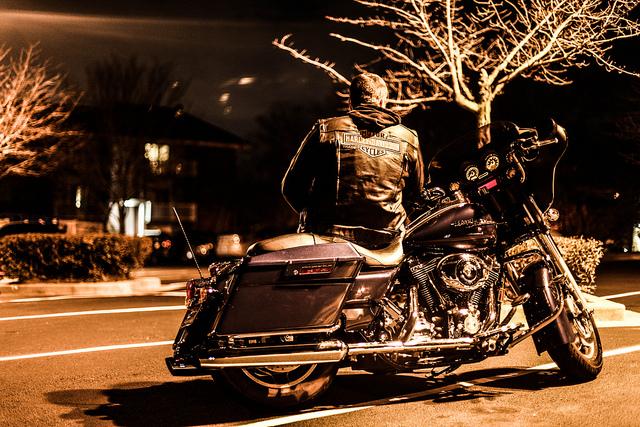What brand of motorcycle is that?
Write a very short answer. Harley. Is the man riding?
Quick response, please. Motorcycle. What objects are in the background?
Short answer required. House trees. 